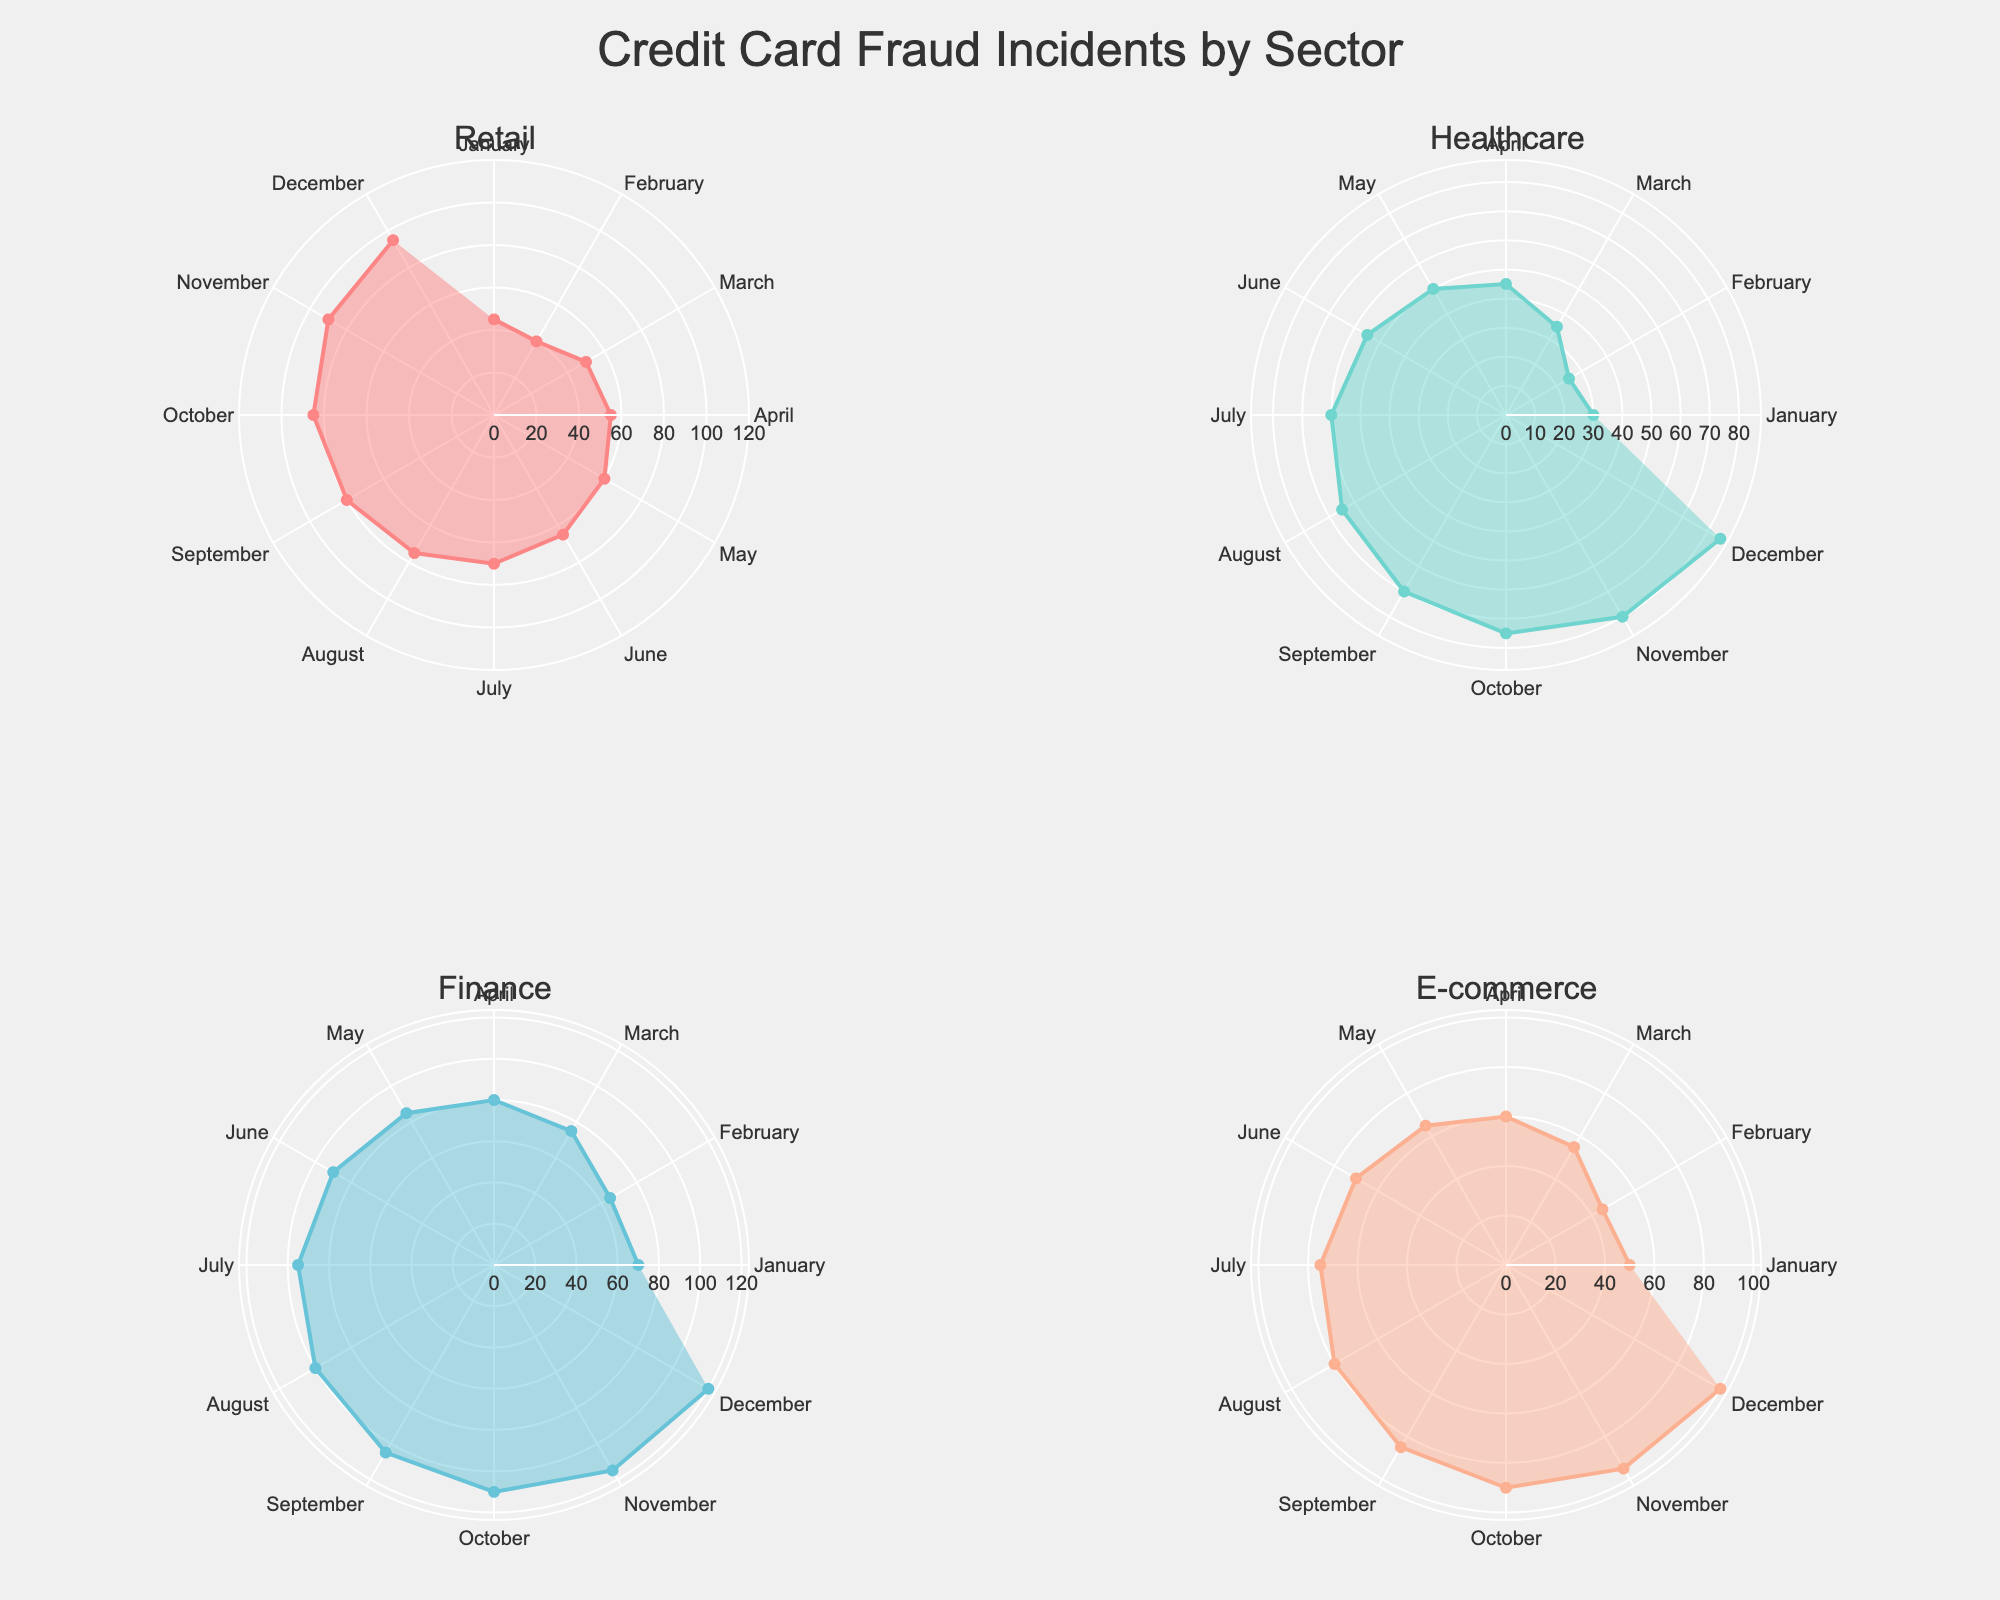Which sector has the highest number of credit card fraud incidents in December? To find the sector with the highest number of incidents in December, look at the outermost data points in each subplot for the month of December. Finance has 120 incidents, which is the highest among all sectors.
Answer: Finance How many credit card fraud incidents occurred in the retail sector in April? In the subplot for the retail sector, the data point corresponding to April is 55, which indicates the number of incidents.
Answer: 55 Which sector shows a consistent increase in credit card fraud incidents from January to December? By examining the pattern in each subplot, the Finance sector shows a consistent increase in incidents every month, starting from 70 in January up to 120 in December.
Answer: Finance What is the total number of credit card fraud incidents in the healthcare sector for the entire year? Sum the incidents for each month in the healthcare sector: 30 + 25 + 35 + 45 + 50 + 55 + 60 + 65 + 70 + 75 + 80 + 85 = 675
Answer: 675 Which month has the highest number of credit card fraud incidents across all sectors combined? Find the month that has the highest cumulative incidents by summing incidents for each month across all sectors. December has the highest total: 95 + 85 + 120 + 100 = 400
Answer: December By how many incidents does the number of credit card fraud incidents in the retail sector in July exceed those in the e-commerce sector in July? In July, the retail sector has 70 incidents and the e-commerce sector has 75 incidents. 70 (Retail) - 75 (E-commerce) = -5
Answer: -5 Which sector has the smallest difference between the number of credit card fraud incidents in January and December? Calculate the difference for each sector: Retail (95-45=50), Healthcare (85-30=55), Finance (120-70=50), E-commerce (100-50=50). The smallest difference is 50, which is found in the Retail, Finance, and E-commerce sectors.
Answer: Retail, Finance, E-commerce Compare the number of credit card fraud incidents between the retail and healthcare sectors in November. Which sector had more incidents and by how much? In November, Retail has 90 incidents, and Healthcare has 80 incidents. Retail has more incidents than Healthcare by 10 (90 - 80 = 10).
Answer: Retail, 10 Is there any month where the retail sector had exactly the same number of fraud incidents as the e-commerce sector? Check each month for equality in the data points of Retail and E-commerce sectors; neither sector has the same number of incidents in any given month.
Answer: No 